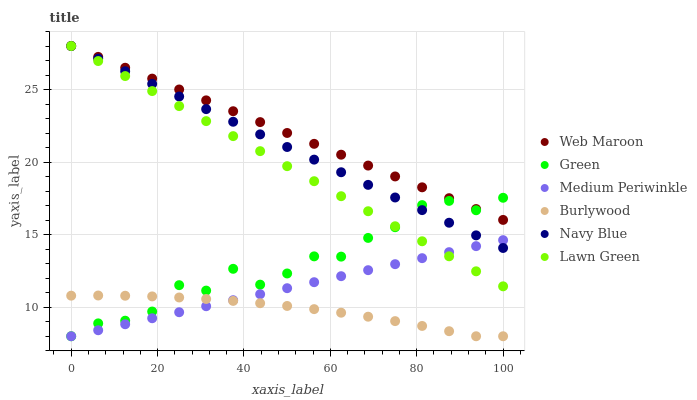Does Burlywood have the minimum area under the curve?
Answer yes or no. Yes. Does Web Maroon have the maximum area under the curve?
Answer yes or no. Yes. Does Medium Periwinkle have the minimum area under the curve?
Answer yes or no. No. Does Medium Periwinkle have the maximum area under the curve?
Answer yes or no. No. Is Lawn Green the smoothest?
Answer yes or no. Yes. Is Green the roughest?
Answer yes or no. Yes. Is Medium Periwinkle the smoothest?
Answer yes or no. No. Is Medium Periwinkle the roughest?
Answer yes or no. No. Does Medium Periwinkle have the lowest value?
Answer yes or no. Yes. Does Navy Blue have the lowest value?
Answer yes or no. No. Does Web Maroon have the highest value?
Answer yes or no. Yes. Does Medium Periwinkle have the highest value?
Answer yes or no. No. Is Medium Periwinkle less than Web Maroon?
Answer yes or no. Yes. Is Navy Blue greater than Burlywood?
Answer yes or no. Yes. Does Lawn Green intersect Navy Blue?
Answer yes or no. Yes. Is Lawn Green less than Navy Blue?
Answer yes or no. No. Is Lawn Green greater than Navy Blue?
Answer yes or no. No. Does Medium Periwinkle intersect Web Maroon?
Answer yes or no. No. 